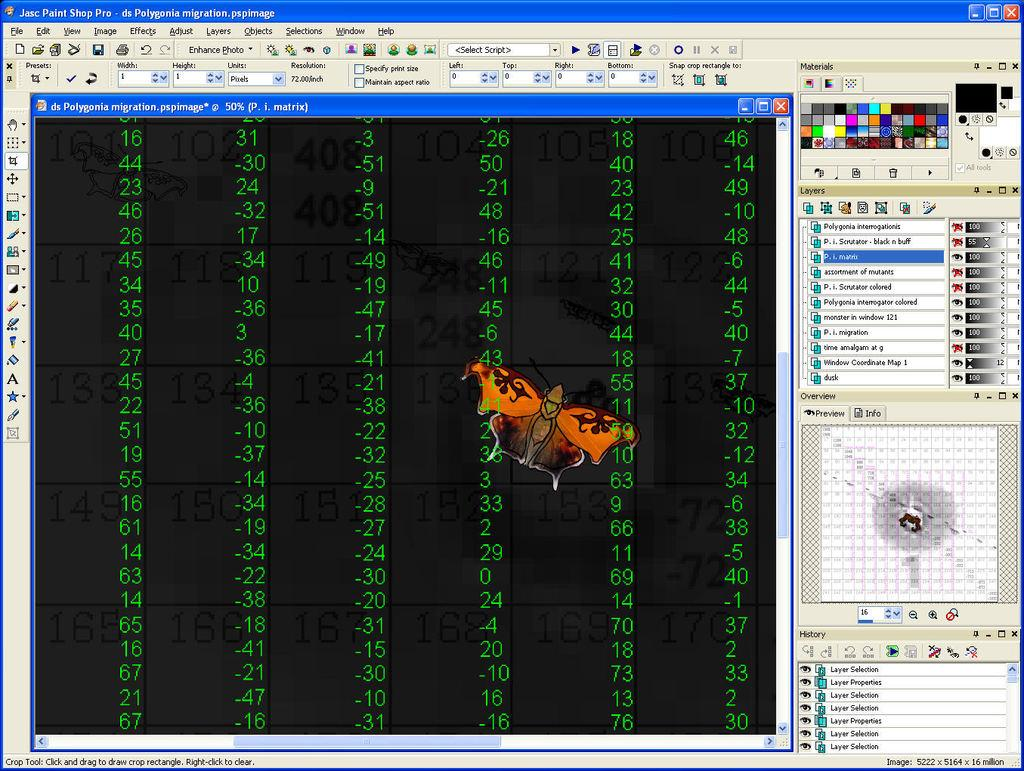What is the main subject of the image? The main subject of the image is a computer's page. What can be seen on the computer's page? There are numbers and text on the computer's page. Are there any other elements in the image besides the computer's page? Yes, there is a butterfly in the image. What type of bread can be seen in the image? There is no bread present in the image; it features a computer's page with numbers and text, along with a butterfly. 